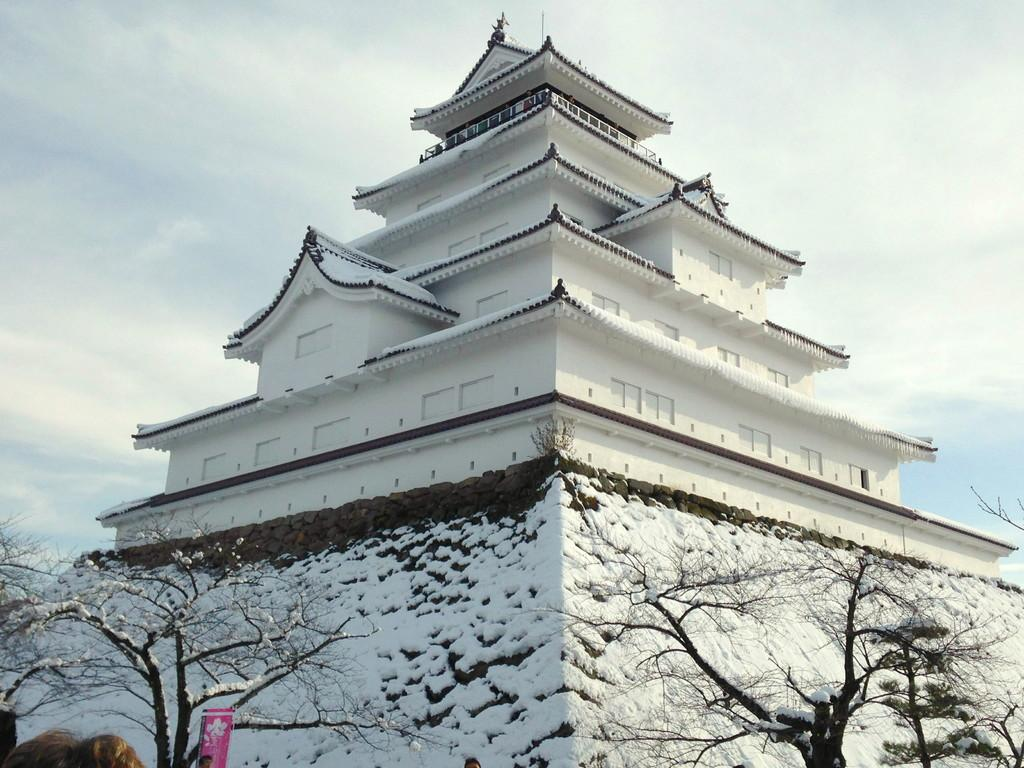What type of structure is visible in the image? There is a building in the image. What other natural elements can be seen in the image? Trees are present in the image. How is the building and trees depicted in the image? The building and trees are covered with snow. What type of bubble can be seen in the image? There is no bubble present in the image; it features a building and trees covered with snow. How does the throat of the building appear in the image? The image does not depict a building with a throat, as buildings do not have throats. 